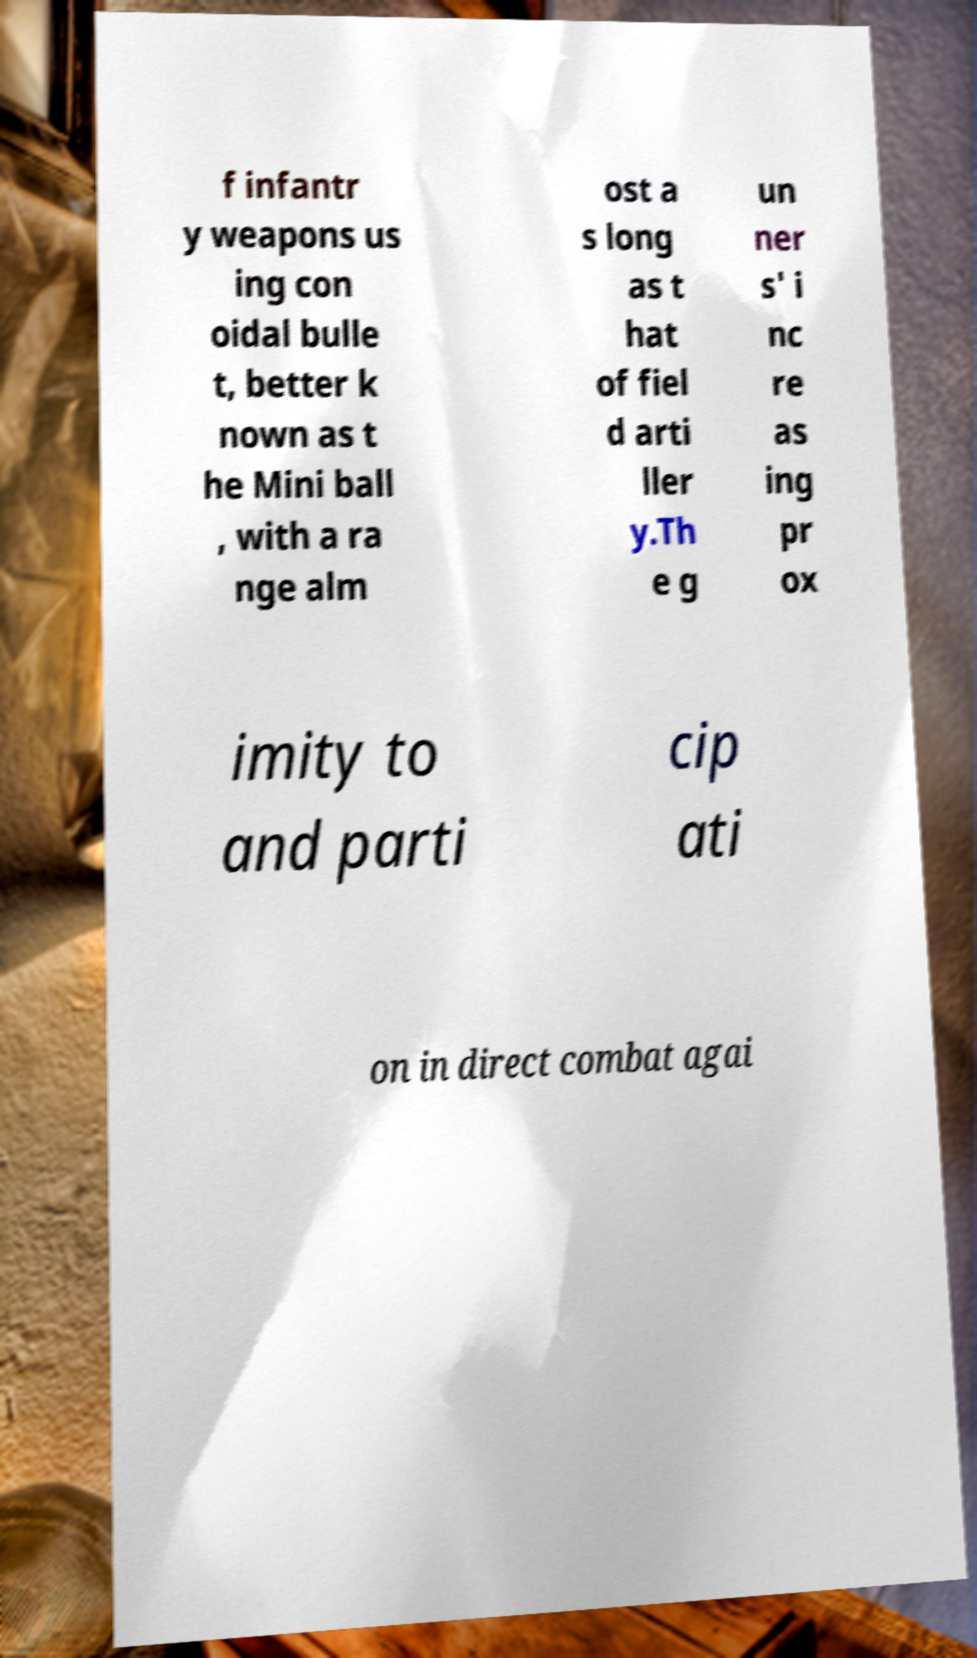Please read and relay the text visible in this image. What does it say? f infantr y weapons us ing con oidal bulle t, better k nown as t he Mini ball , with a ra nge alm ost a s long as t hat of fiel d arti ller y.Th e g un ner s' i nc re as ing pr ox imity to and parti cip ati on in direct combat agai 